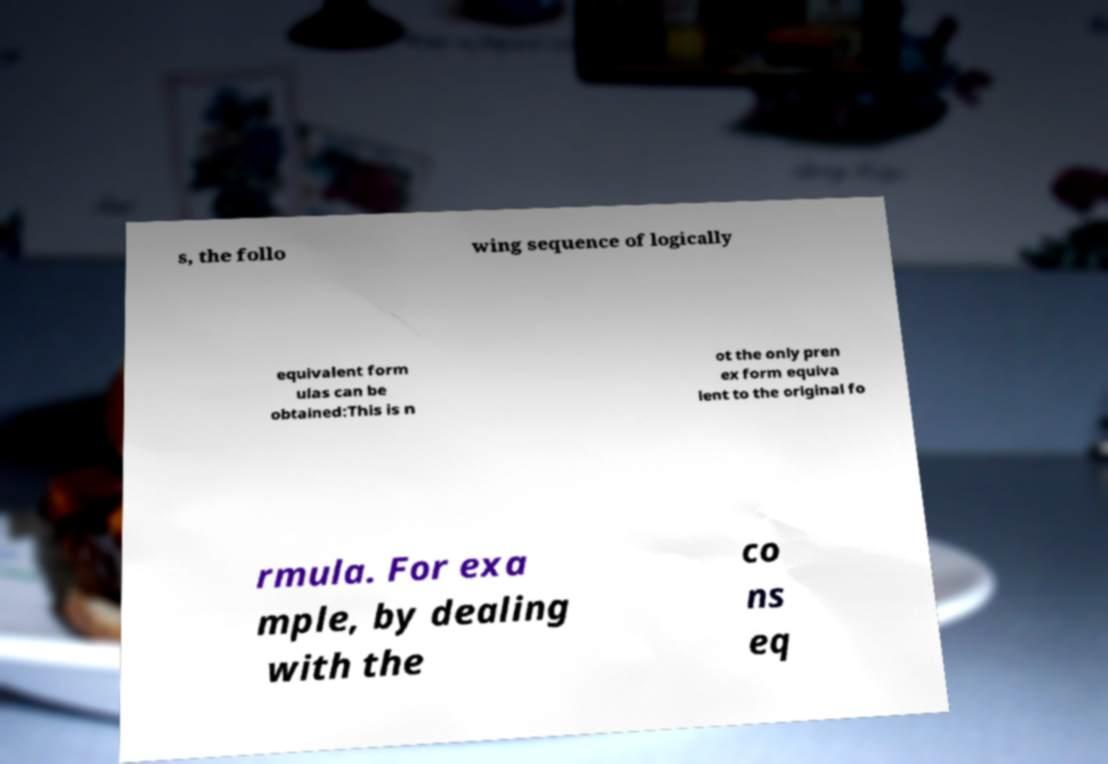Please read and relay the text visible in this image. What does it say? s, the follo wing sequence of logically equivalent form ulas can be obtained:This is n ot the only pren ex form equiva lent to the original fo rmula. For exa mple, by dealing with the co ns eq 